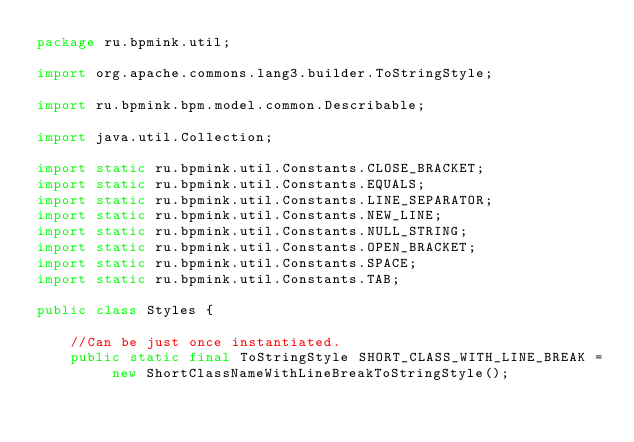<code> <loc_0><loc_0><loc_500><loc_500><_Java_>package ru.bpmink.util;

import org.apache.commons.lang3.builder.ToStringStyle;

import ru.bpmink.bpm.model.common.Describable;

import java.util.Collection;

import static ru.bpmink.util.Constants.CLOSE_BRACKET;
import static ru.bpmink.util.Constants.EQUALS;
import static ru.bpmink.util.Constants.LINE_SEPARATOR;
import static ru.bpmink.util.Constants.NEW_LINE;
import static ru.bpmink.util.Constants.NULL_STRING;
import static ru.bpmink.util.Constants.OPEN_BRACKET;
import static ru.bpmink.util.Constants.SPACE;
import static ru.bpmink.util.Constants.TAB;

public class Styles {

    //Can be just once instantiated.
    public static final ToStringStyle SHORT_CLASS_WITH_LINE_BREAK = new ShortClassNameWithLineBreakToStringStyle();
</code> 